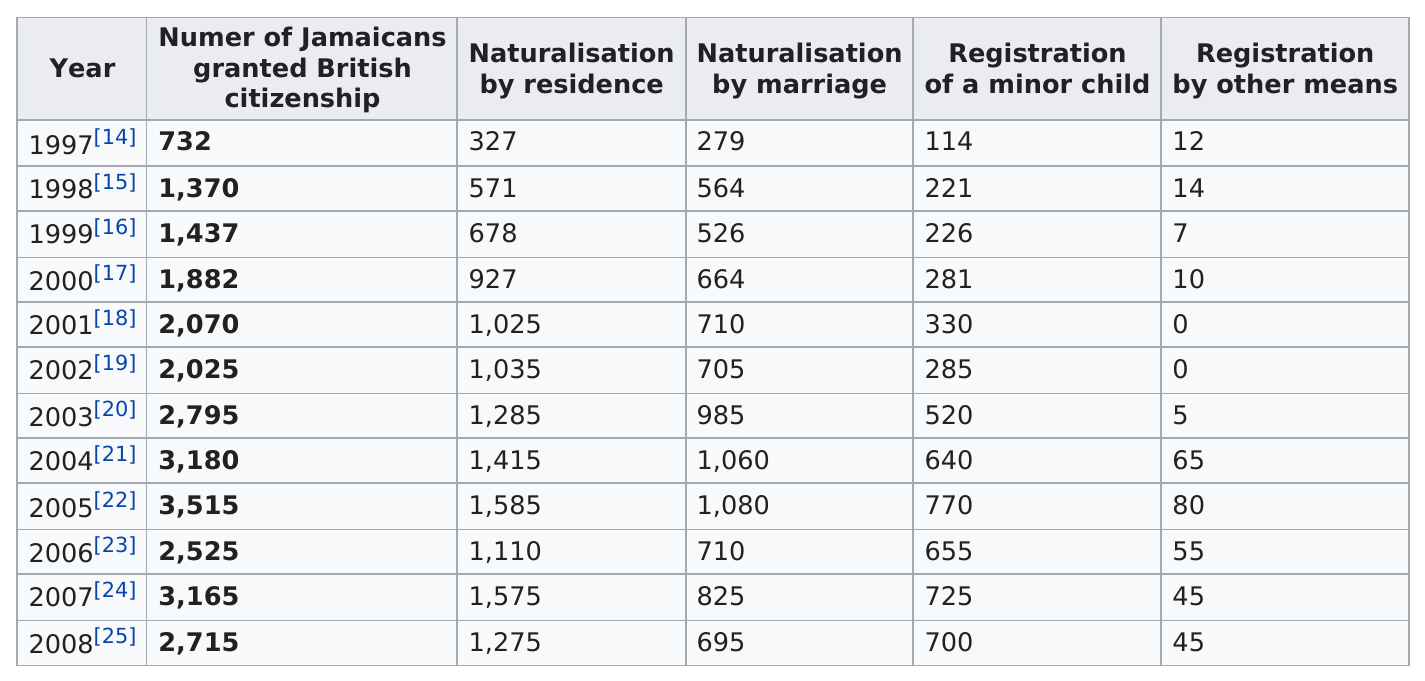Indicate a few pertinent items in this graphic. In 2005, approximately 8,405 Jamaicans were granted British citizenship. In 1997, there were 114 minor children registered, making it the only year with this number of registered minors. In 2005, the largest number of Jamaicans were granted British citizenship. From 2001 to 2002, there was no registration of births by other means. In 2005, the number of registrations of minors was the greatest. 